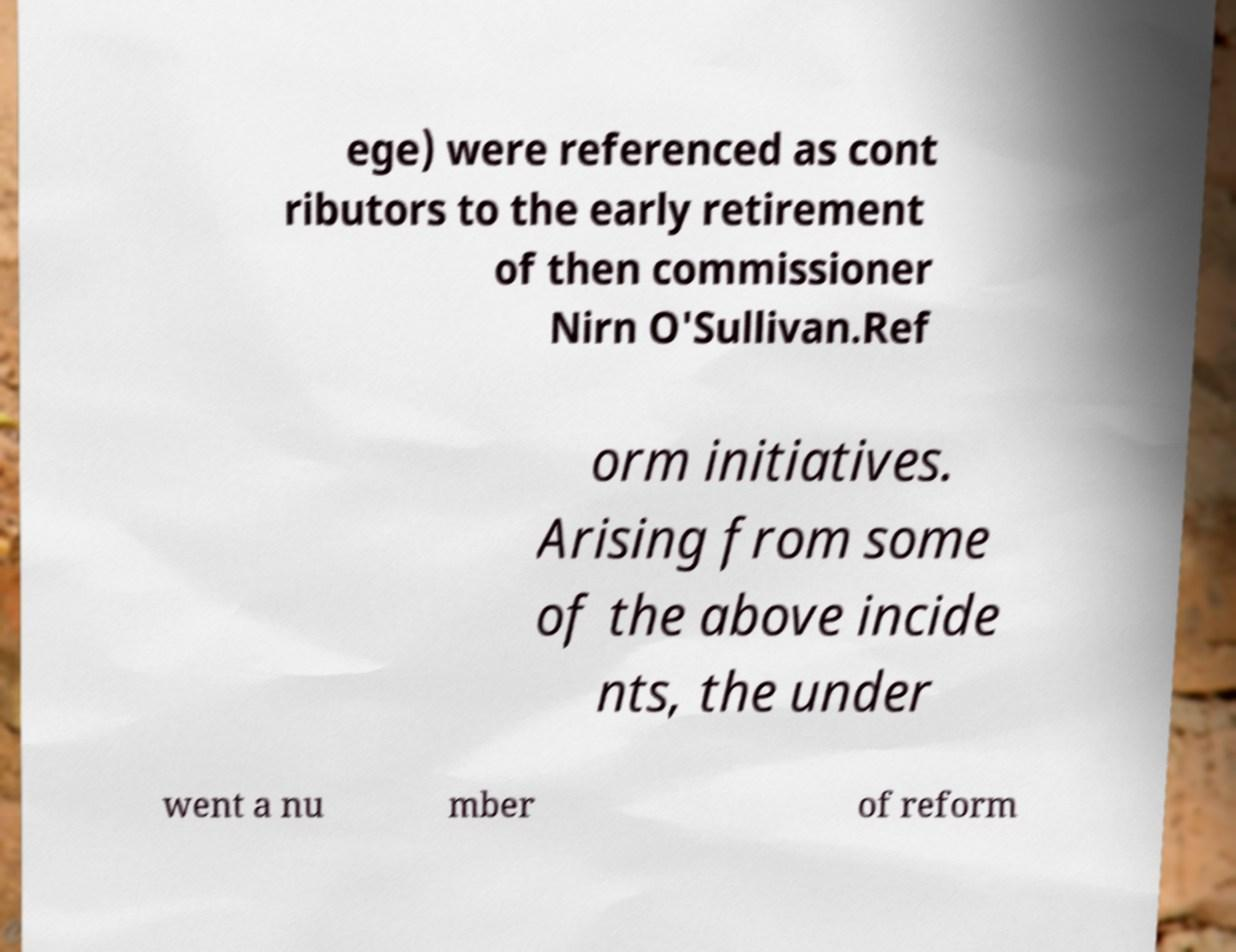For documentation purposes, I need the text within this image transcribed. Could you provide that? ege) were referenced as cont ributors to the early retirement of then commissioner Nirn O'Sullivan.Ref orm initiatives. Arising from some of the above incide nts, the under went a nu mber of reform 